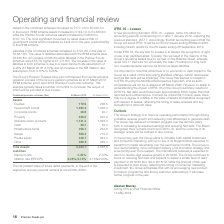According to Premier Foods Plc's financial document, What was the increase in the assets in the combined schemes in 2019? According to the financial document, £177.1m. The relevant text states: "Assets in the combined schemes increased by £177.1m to £5,040.7m in the period. RHM scheme assets increased by £149.1m to £4,333.6m while the Premier Fo..." Also, What was the increase in the liabilities in the combined schemes in 2019? According to the financial document, £121.0m. The relevant text states: "Liabilities in the combined schemes increased by £121.0m in the year to £4,667.6m. The value of liabilities associated with the RHM scheme were £3,495.8m, an..." Also, What was the net present value of future-deficit payments? According to the financial document, £300–320m. The relevant text states: "f the respective recovery periods remains at circa £300–320m...." Also, can you calculate: What was the change in equities from 2018 to 2019? Based on the calculation: 179.5 - 296.5, the result is -117 (in millions). This is based on the information: "Assets Equities 179.5 296.5 Government bonds 1,490.4 1,046.4 Corporate bonds 26.9 20.7 Property 436.5 391.0 Absolute return pro Assets Equities 179.5 296.5 Government bonds 1,490.4 1,046.4 Corporate b..." The key data points involved are: 179.5, 296.5. Also, can you calculate: What was the average government bonds for 2018 and 2019? To answer this question, I need to perform calculations using the financial data. The calculation is: (1,490.4 + 1,046.4) / 2, which equals 1268.4 (in millions). This is based on the information: "Assets Equities 179.5 296.5 Government bonds 1,490.4 1,046.4 Corporate bonds 26.9 20.7 Property 436.5 391.0 Absolute return products 1,141.2 1,323.3 Cas ets Equities 179.5 296.5 Government bonds 1,490..." The key data points involved are: 1,046.4, 1,490.4. Also, can you calculate: What was the change in the corporate bonds from 2018 to 2019? Based on the calculation: 26.9 - 20.7, the result is 6.2 (in millions). This is based on the information: "rnment bonds 1,490.4 1,046.4 Corporate bonds 26.9 20.7 Property 436.5 391.0 Absolute return products 1,141.2 1,323.3 Cash 38.1 32.4 Infrastructure funds 2 Government bonds 1,490.4 1,046.4 Corporate bo..." The key data points involved are: 20.7, 26.9. 